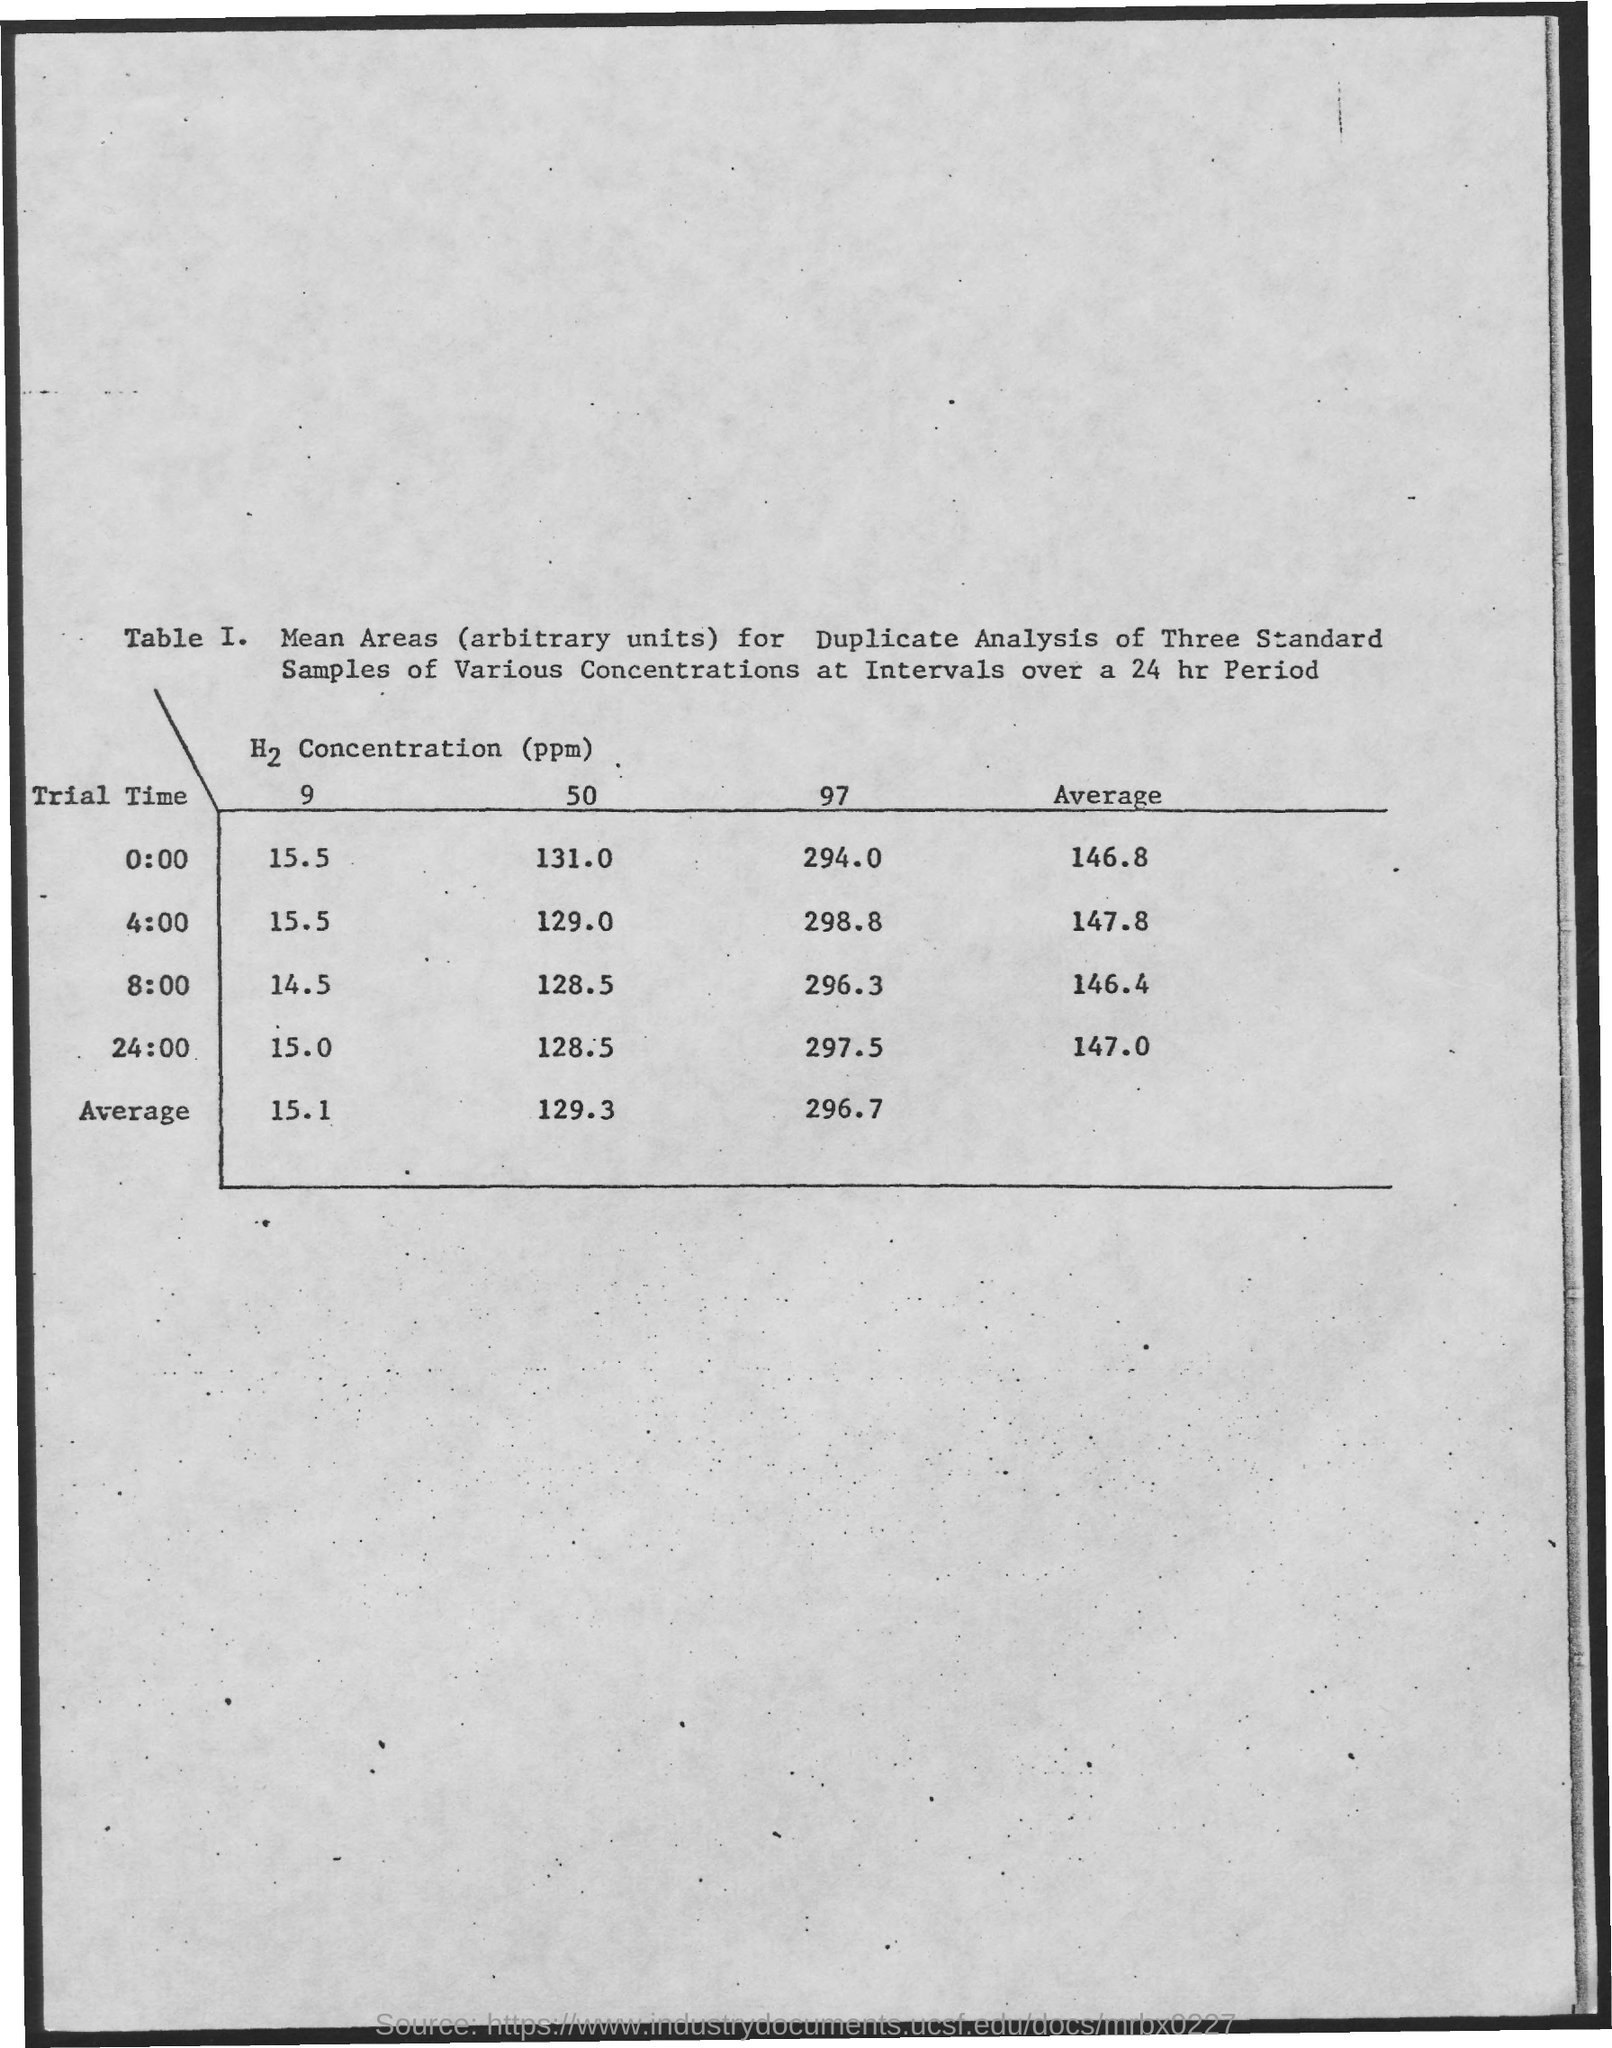What is the Average for trial time 4:00?
Offer a terse response. 147.8. What is the Average for trial time 0:00?
Offer a terse response. 146.8. What is the Average for trial time 8.00?
Your response must be concise. 146.4. What is the Average for trial time 24:00?
Your answer should be very brief. 147.0. 